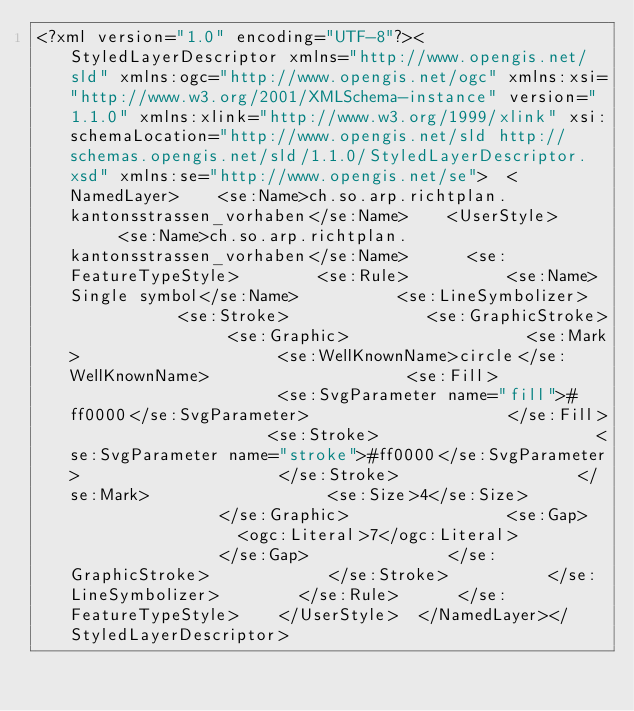<code> <loc_0><loc_0><loc_500><loc_500><_Scheme_><?xml version="1.0" encoding="UTF-8"?><StyledLayerDescriptor xmlns="http://www.opengis.net/sld" xmlns:ogc="http://www.opengis.net/ogc" xmlns:xsi="http://www.w3.org/2001/XMLSchema-instance" version="1.1.0" xmlns:xlink="http://www.w3.org/1999/xlink" xsi:schemaLocation="http://www.opengis.net/sld http://schemas.opengis.net/sld/1.1.0/StyledLayerDescriptor.xsd" xmlns:se="http://www.opengis.net/se">  <NamedLayer>    <se:Name>ch.so.arp.richtplan.kantonsstrassen_vorhaben</se:Name>    <UserStyle>      <se:Name>ch.so.arp.richtplan.kantonsstrassen_vorhaben</se:Name>      <se:FeatureTypeStyle>        <se:Rule>          <se:Name>Single symbol</se:Name>          <se:LineSymbolizer>            <se:Stroke>              <se:GraphicStroke>                <se:Graphic>                  <se:Mark>                    <se:WellKnownName>circle</se:WellKnownName>                    <se:Fill>                      <se:SvgParameter name="fill">#ff0000</se:SvgParameter>                    </se:Fill>                    <se:Stroke>                      <se:SvgParameter name="stroke">#ff0000</se:SvgParameter>                    </se:Stroke>                  </se:Mark>                  <se:Size>4</se:Size>                </se:Graphic>                <se:Gap>                  <ogc:Literal>7</ogc:Literal>                </se:Gap>              </se:GraphicStroke>            </se:Stroke>          </se:LineSymbolizer>        </se:Rule>      </se:FeatureTypeStyle>    </UserStyle>  </NamedLayer></StyledLayerDescriptor></code> 